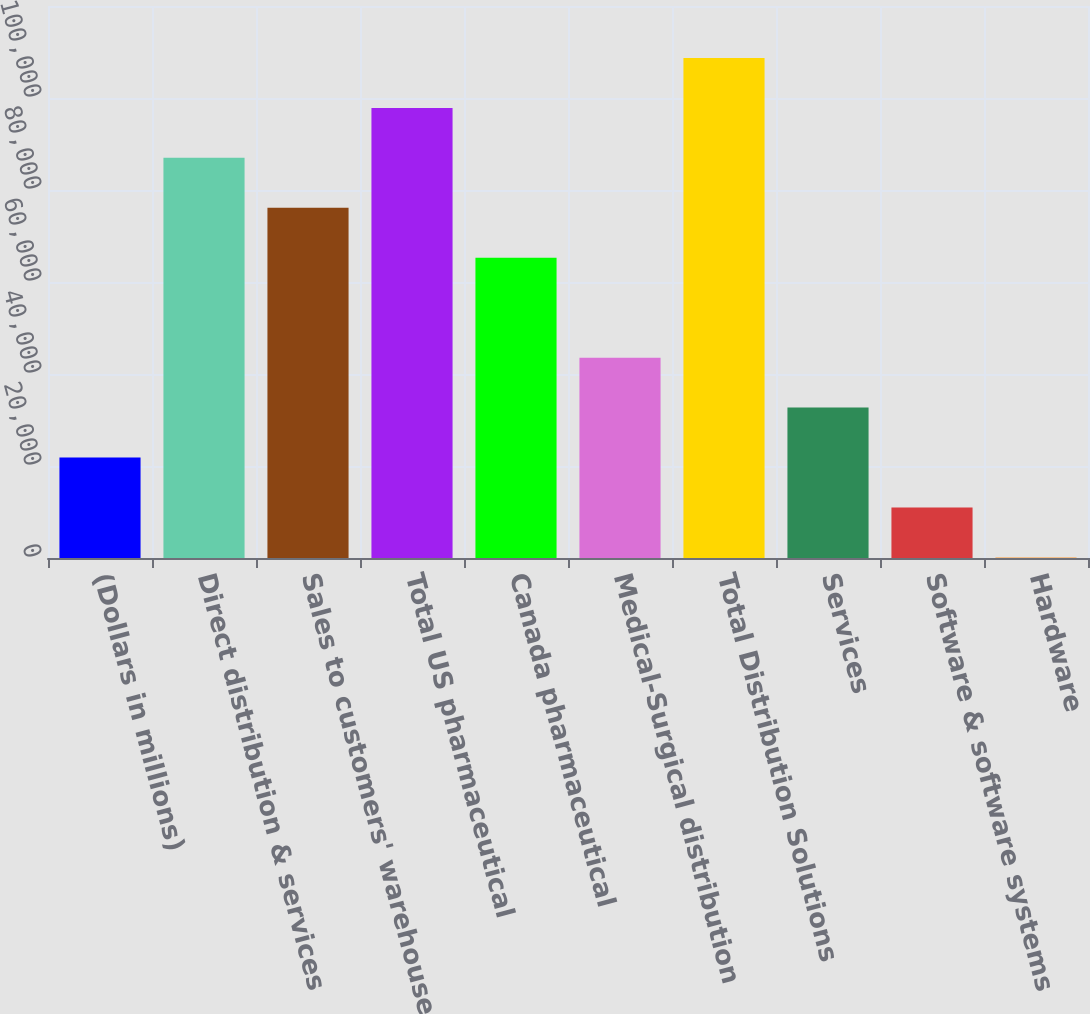<chart> <loc_0><loc_0><loc_500><loc_500><bar_chart><fcel>(Dollars in millions)<fcel>Direct distribution & services<fcel>Sales to customers' warehouses<fcel>Total US pharmaceutical<fcel>Canada pharmaceutical<fcel>Medical-Surgical distribution<fcel>Total Distribution Solutions<fcel>Services<fcel>Software & software systems<fcel>Hardware<nl><fcel>21831.6<fcel>86984.4<fcel>76125.6<fcel>97843.2<fcel>65266.8<fcel>43549.2<fcel>108702<fcel>32690.4<fcel>10972.8<fcel>114<nl></chart> 